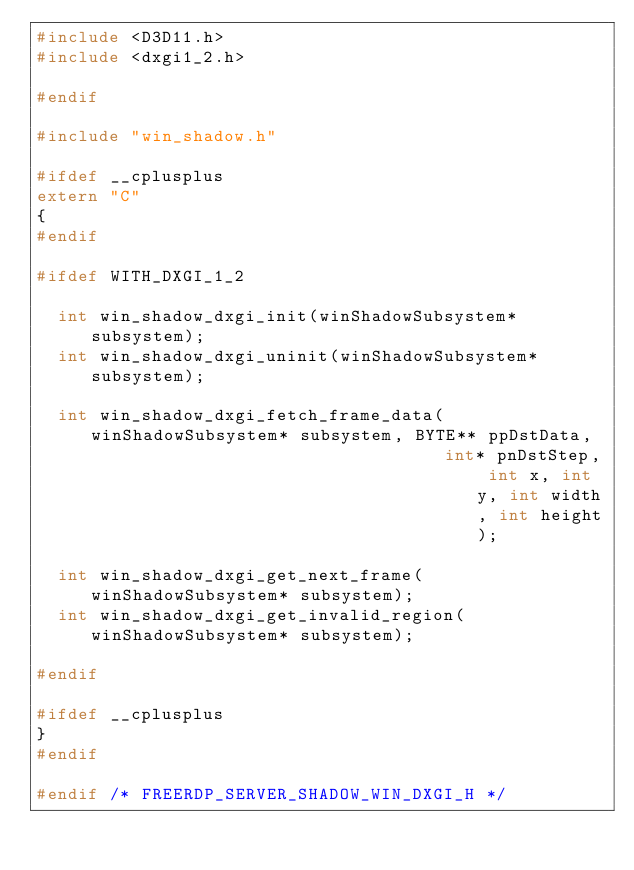<code> <loc_0><loc_0><loc_500><loc_500><_C_>#include <D3D11.h>
#include <dxgi1_2.h>

#endif

#include "win_shadow.h"

#ifdef __cplusplus
extern "C"
{
#endif

#ifdef WITH_DXGI_1_2

	int win_shadow_dxgi_init(winShadowSubsystem* subsystem);
	int win_shadow_dxgi_uninit(winShadowSubsystem* subsystem);

	int win_shadow_dxgi_fetch_frame_data(winShadowSubsystem* subsystem, BYTE** ppDstData,
	                                     int* pnDstStep, int x, int y, int width, int height);

	int win_shadow_dxgi_get_next_frame(winShadowSubsystem* subsystem);
	int win_shadow_dxgi_get_invalid_region(winShadowSubsystem* subsystem);

#endif

#ifdef __cplusplus
}
#endif

#endif /* FREERDP_SERVER_SHADOW_WIN_DXGI_H */
</code> 